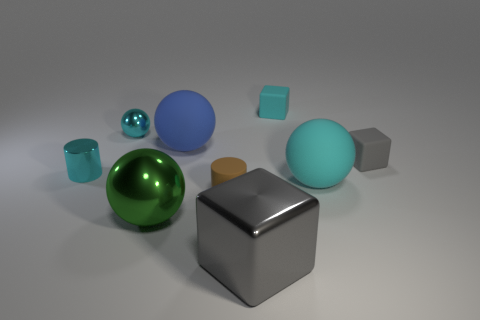What is the material of the tiny block that is the same color as the small shiny cylinder?
Offer a very short reply. Rubber. How many green metal balls have the same size as the brown thing?
Make the answer very short. 0. There is another big object that is made of the same material as the large green thing; what color is it?
Your response must be concise. Gray. Is the number of large rubber objects less than the number of tiny brown cylinders?
Your answer should be very brief. No. How many brown objects are small objects or tiny rubber things?
Offer a terse response. 1. What number of objects are on the right side of the gray metallic thing and in front of the small cyan block?
Your response must be concise. 2. Does the cyan cylinder have the same material as the green ball?
Give a very brief answer. Yes. There is a gray matte thing that is the same size as the cyan block; what is its shape?
Ensure brevity in your answer.  Cube. Are there more matte cubes than green things?
Provide a succinct answer. Yes. The cyan object that is both in front of the tiny ball and on the left side of the gray shiny thing is made of what material?
Provide a short and direct response. Metal. 